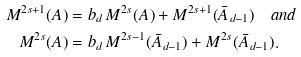<formula> <loc_0><loc_0><loc_500><loc_500>M ^ { 2 s + 1 } ( A ) & = b _ { d } \, M ^ { 2 s } ( A ) + M ^ { 2 s + 1 } ( \bar { A } _ { d - 1 } ) \quad a n d \\ M ^ { 2 s } ( A ) & = b _ { d } \, M ^ { 2 s - 1 } ( \bar { A } _ { d - 1 } ) + M ^ { 2 s } ( \bar { A } _ { d - 1 } ) .</formula> 